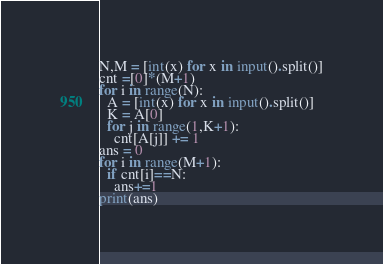Convert code to text. <code><loc_0><loc_0><loc_500><loc_500><_Python_>N,M = [int(x) for x in input().split()]
cnt =[0]*(M+1)
for i in range(N):
  A = [int(x) for x in input().split()]
  K = A[0]
  for j in range(1,K+1):
    cnt[A[j]] += 1
ans = 0
for i in range(M+1):
  if cnt[i]==N:
    ans+=1
print(ans)</code> 